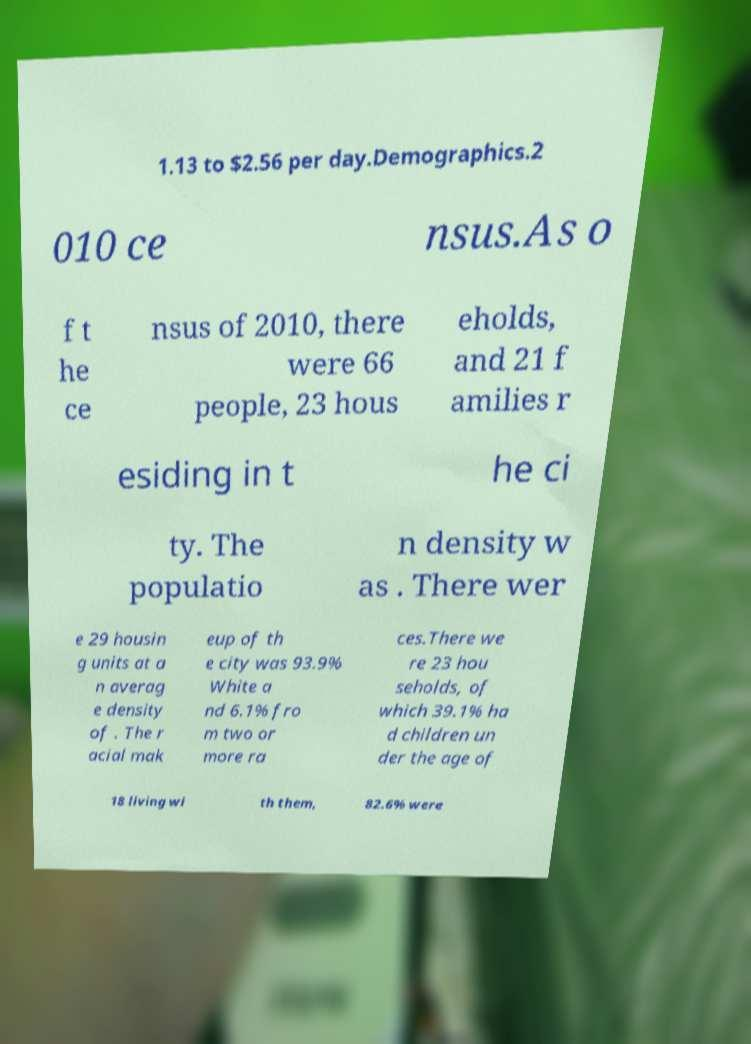Could you extract and type out the text from this image? 1.13 to $2.56 per day.Demographics.2 010 ce nsus.As o f t he ce nsus of 2010, there were 66 people, 23 hous eholds, and 21 f amilies r esiding in t he ci ty. The populatio n density w as . There wer e 29 housin g units at a n averag e density of . The r acial mak eup of th e city was 93.9% White a nd 6.1% fro m two or more ra ces.There we re 23 hou seholds, of which 39.1% ha d children un der the age of 18 living wi th them, 82.6% were 